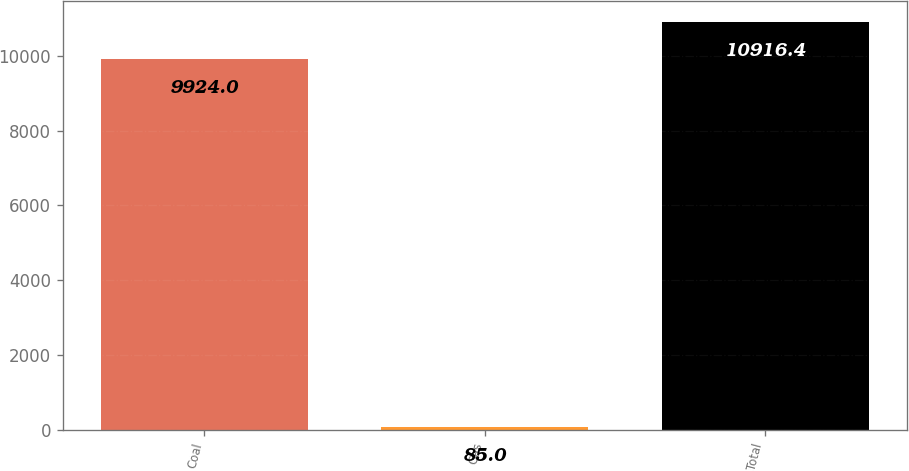Convert chart. <chart><loc_0><loc_0><loc_500><loc_500><bar_chart><fcel>Coal<fcel>Gas<fcel>Total<nl><fcel>9924<fcel>85<fcel>10916.4<nl></chart> 